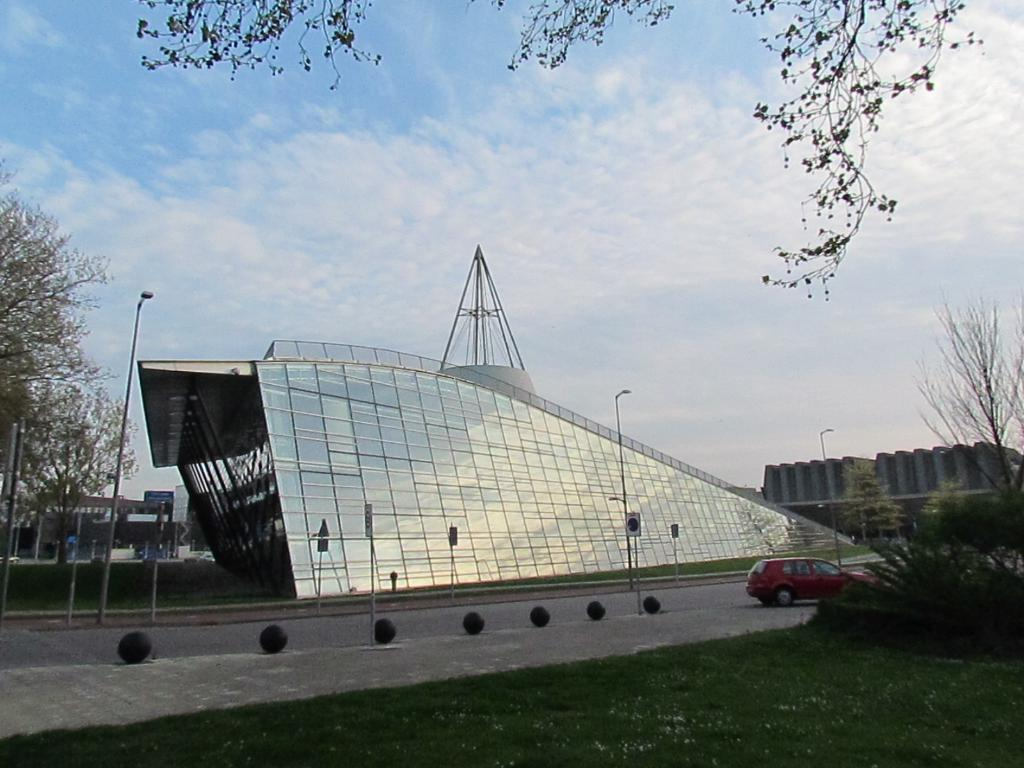What type of building is in the center of the image? There is a commercial building in the center of the image. What can be seen at the bottom side of the image? There is grassland at the bottom side of the image. What type of soup is being served in the image? There is no soup present in the image. 